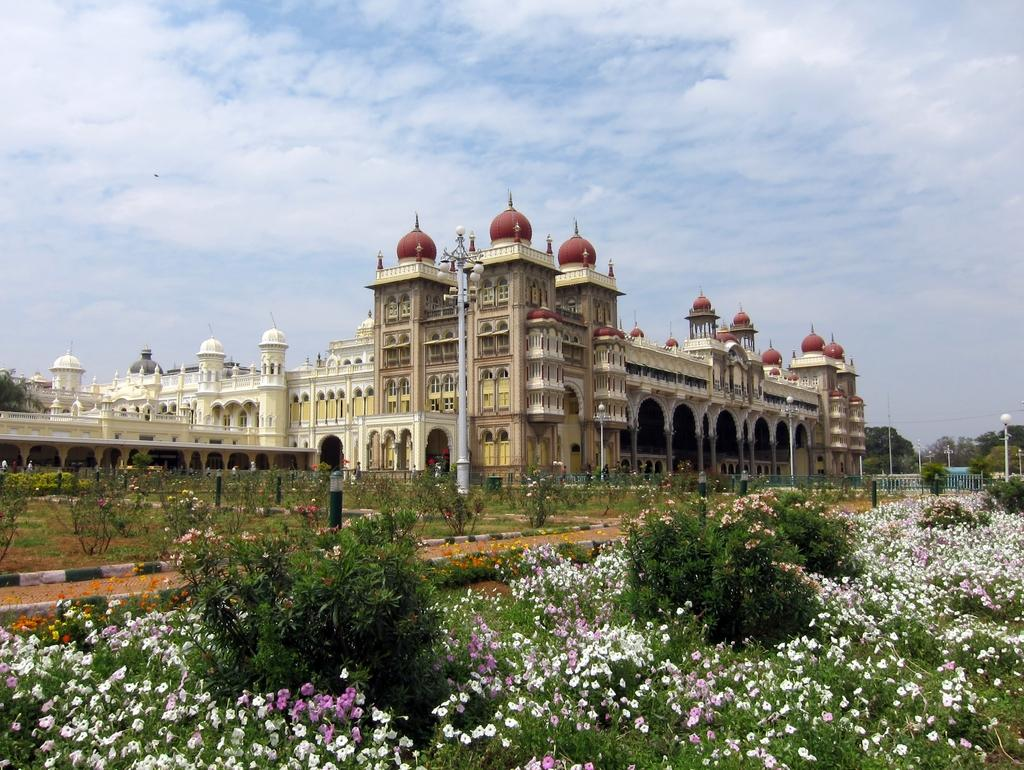What type of structure is present in the image? There is a building in the image. What is located in front of the building? There is a garden with flower plants in front of the building. What can be found in the garden besides the flower plants? There is a pole with lights in the garden. What is visible behind the building? There are trees visible behind the building. How many stars can be seen covering the building in the image? There are no stars visible in the image, and they are not covering the building. 